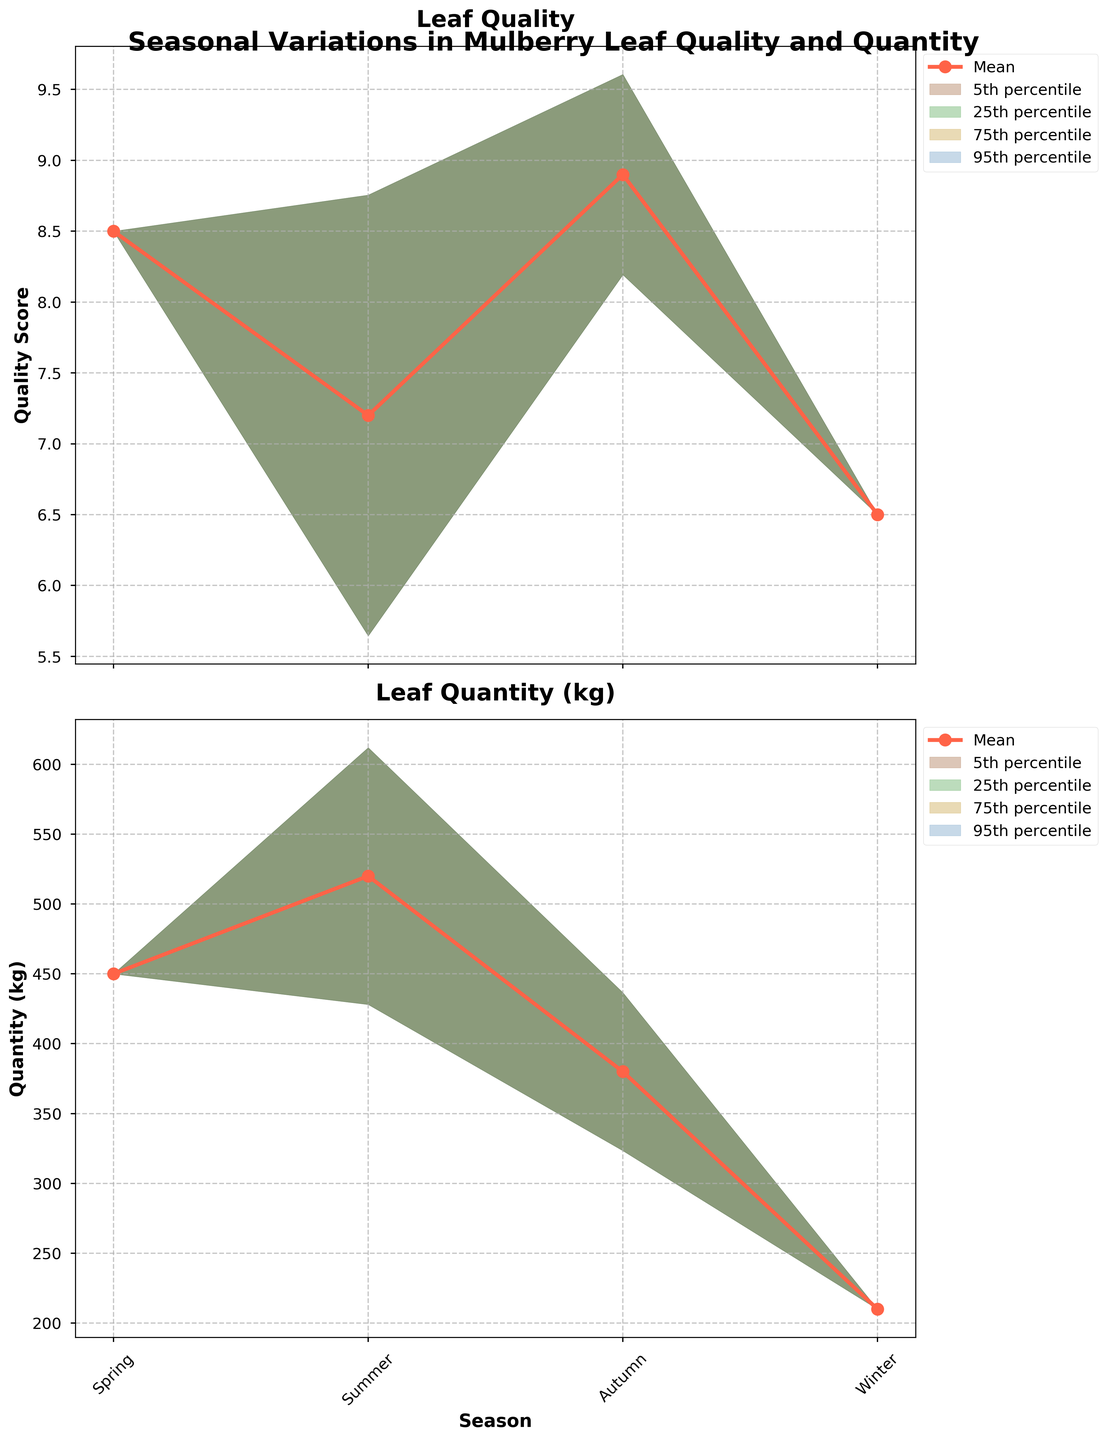what is the title of the figure? The title of the figure is generally displayed at the top of the chart, and it provides a summary of what the chart represents. In this case, the title is prominently placed above the two subplots.
Answer: Seasonal Variations in Mulberry Leaf Quality and Quantity How many seasons are represented in the figure? The x-axis of both subplots lists the different seasons being considered. These are typically four based on the information provided in the data: Spring, Summer, Autumn, and Winter.
Answer: 4 What is the mean leaf quality during Autumn? To find the mean leaf quality for Autumn, locate the Autumn data point on the quality mean line in the leaf quality subplot.
Answer: 8.9 Which season has the highest leaf quantity on average? By examining the mean values plotted for leaf quantity across seasons, you can determine the season with the highest mean value.
Answer: Summer What is the difference in mean leaf quality between Spring and Winter? To calculate this, identify the mean values for Spring and Winter from the leaf quality subplot and subtract the Winter mean from the Spring mean: 8.5 (Spring) - 6.5 (Winter).
Answer: 2.0 How does the variability in leaf quality compare between Summer and Autumn? Comparing the spread of the confidence bands (fill area) around the mean line in the leaf quality subplot will allow us to determine the variability. Summer has a wider spread because its standard deviation is higher.
Answer: Summer has higher variability What is the approximate range of leaf quantity during Winter? To find the range, identify the lower and upper bounds of the confidence band in the Winter section of the leaf quantity subplot. Adding and subtracting approximately 1.3 times the standard deviation to/from the mean gives 210 ± (1.3*30), resulting in approximate boundaries.
Answer: Around 180 to 240 kg Which season has the least variability in leaf quality? The season with the narrowest confidence band in the leaf quality subplot has the least variability. Graphically, this is the season where the shaded area around the mean line is the smallest.
Answer: Autumn What season shows the largest drop in leaf quantity compared to the previous season? This requires checking the difference in values for leaf quantity between consecutive seasons on the plot. Here, the most significant drop can be seen from Autumn to Winter.
Answer: Autumn to Winter What can be inferred about the quality of mulberry leaves in terms of seasonal feeding for silkworms? High-quality leaves are essential, evidenced by the mean leaf quality, and seasonal variability must be considered. Spring and Autumn provide high-quality leaves, beneficial for optimal silkworm feed.
Answer: Spring and Autumn are best for quality 